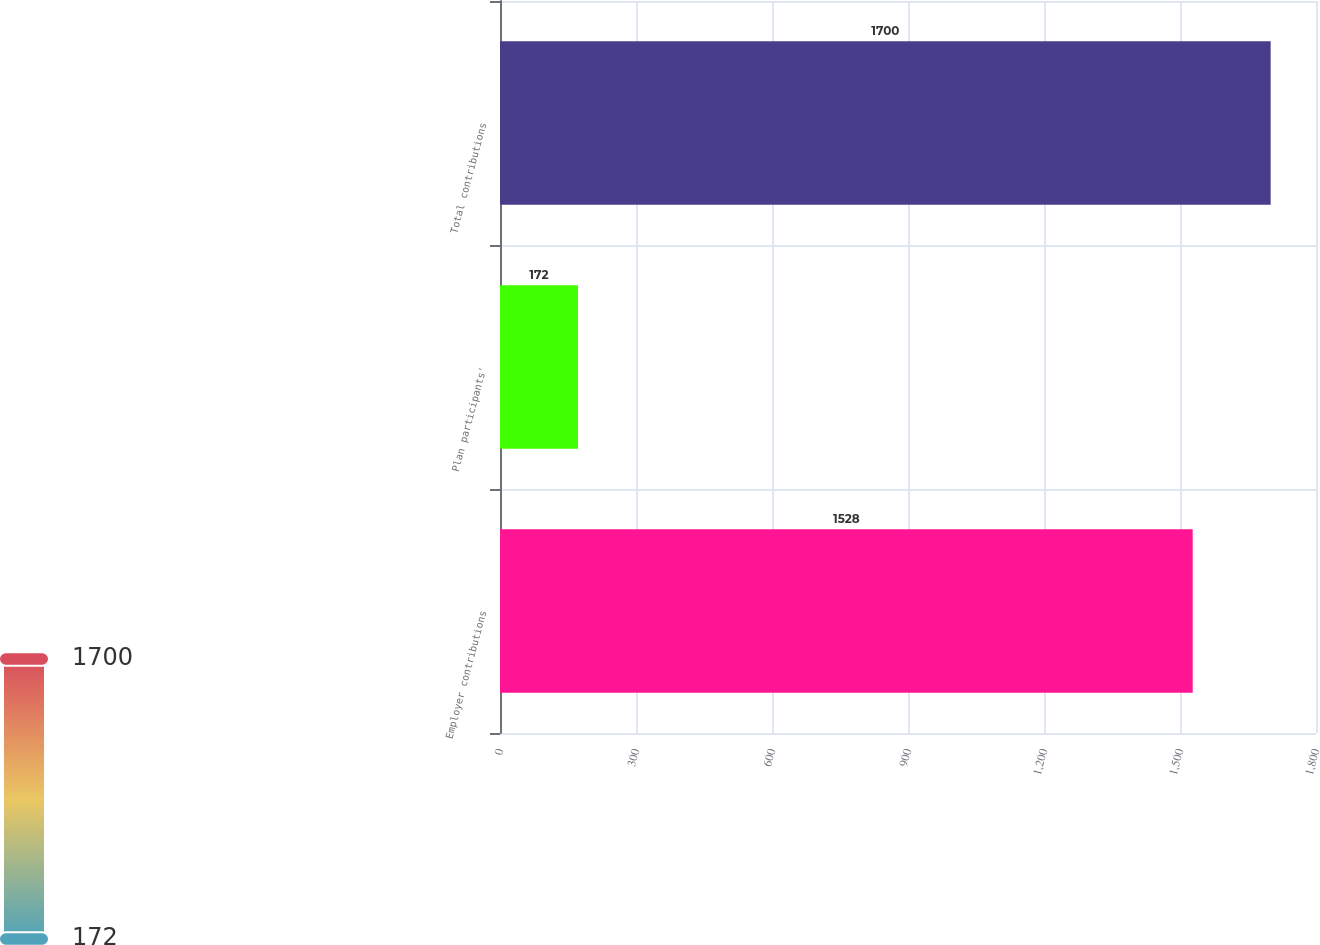Convert chart to OTSL. <chart><loc_0><loc_0><loc_500><loc_500><bar_chart><fcel>Employer contributions<fcel>Plan participants'<fcel>Total contributions<nl><fcel>1528<fcel>172<fcel>1700<nl></chart> 